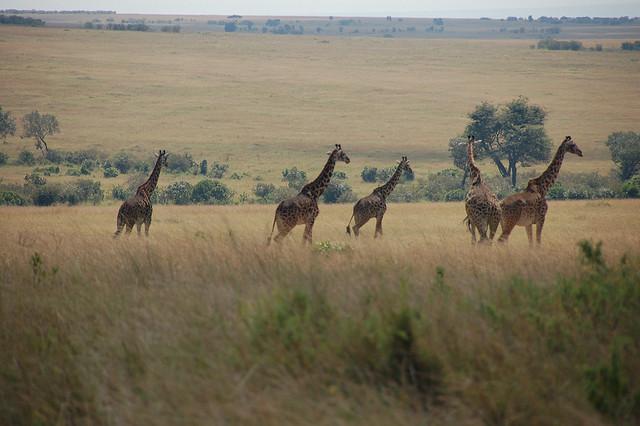Is this a forest?
Write a very short answer. No. Are there any other animals in the pictures besides giraffes?
Write a very short answer. No. How many giraffes are in the picture?
Be succinct. 5. 